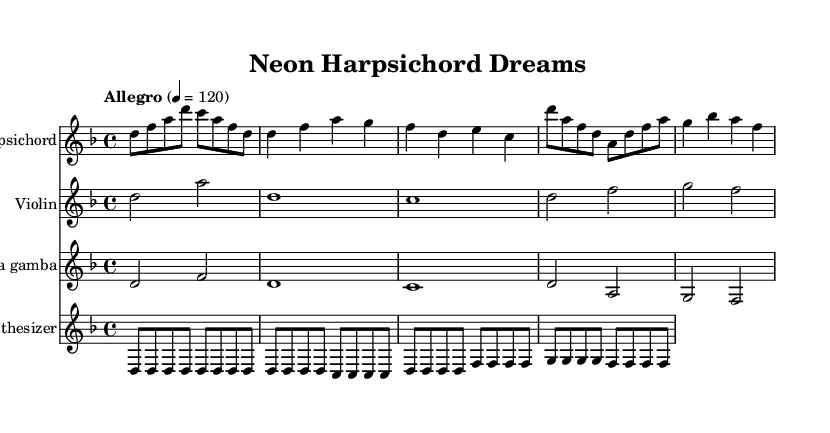What is the key signature of this music? The key signature indicates two flats, which correspond to the key of D minor. The presence of two flat symbols at the beginning of the staff confirms this.
Answer: D minor What is the time signature of this music? The time signature appears at the beginning of the staff as "4/4," indicating that there are four beats in each measure, and each quarter note gets one beat.
Answer: 4/4 What is the tempo marking for this piece? The tempo is indicated as "Allegro," and it is further specified with a metronome marking of 120 beats per minute, meaning the pace is lively and fast.
Answer: Allegro, 120 How many measures are there in the harpsichord part? By counting the horizontal lines separating the measures in the provided harpsichord staff, there are a total of six measures shown.
Answer: 6 What type of instrument is part of this composition? The composition includes the "Viola da gamba," which is specifically indicated in its respective staff section within the sheet music, and it's a characteristic instrument from the Baroque period.
Answer: Viola da gamba Which electronic element is used in this piece? The "Synthesizer" is indicated as one of the staff sections, which is an electronic instrument, adding a contemporary aspect to the composition.
Answer: Synthesizer Which instruments are playing in parallel in measures 3 and 4? Both the "Harpsichord" and "Violin" sections show simultaneous notes being played in their respective measures, indicating a harmonic relationship between them in those bars of the sheet music.
Answer: Harpsichord, Violin 